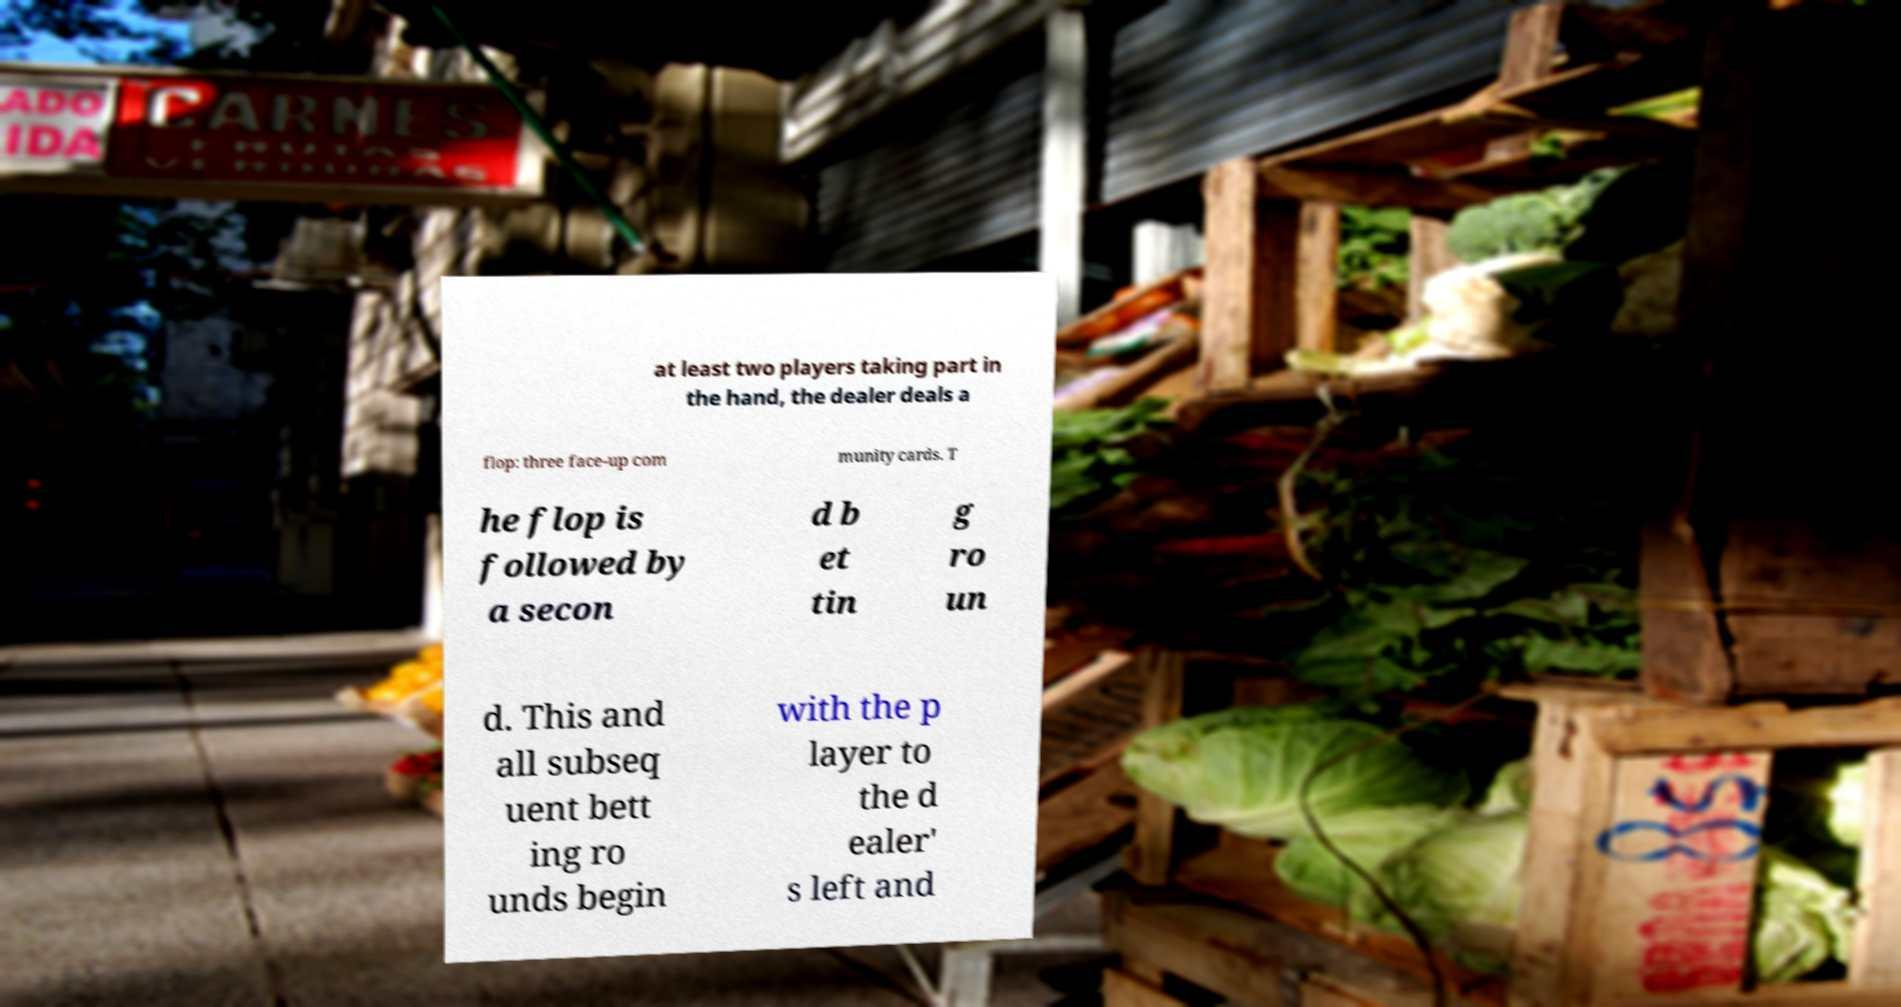I need the written content from this picture converted into text. Can you do that? at least two players taking part in the hand, the dealer deals a flop: three face-up com munity cards. T he flop is followed by a secon d b et tin g ro un d. This and all subseq uent bett ing ro unds begin with the p layer to the d ealer' s left and 